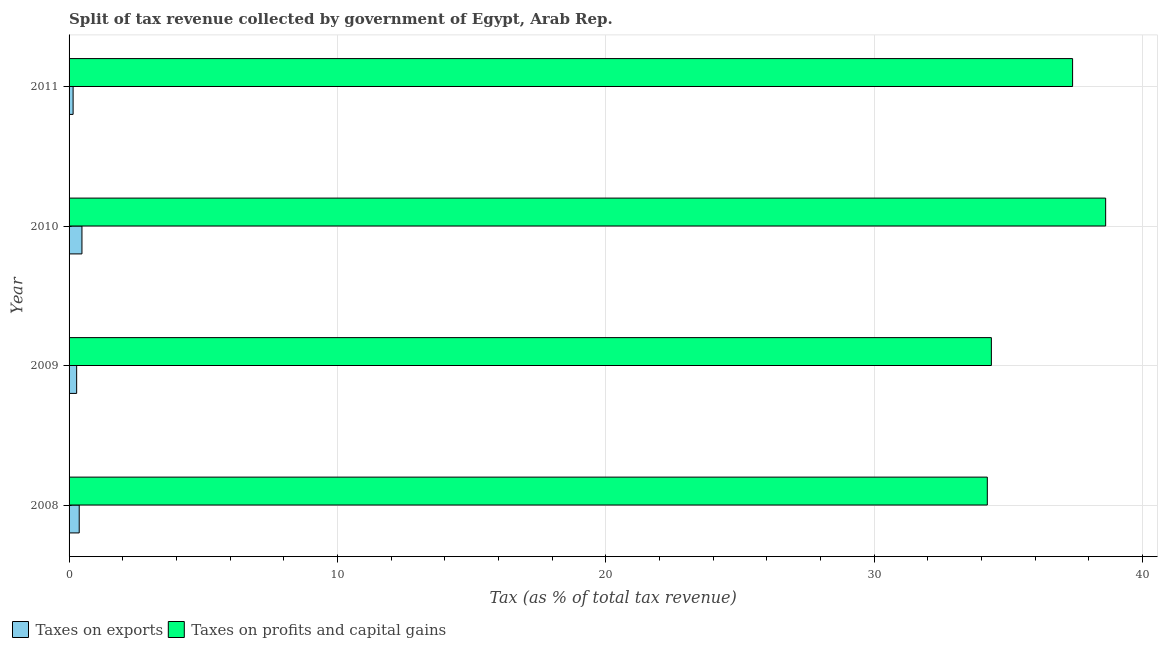Are the number of bars per tick equal to the number of legend labels?
Keep it short and to the point. Yes. How many bars are there on the 1st tick from the top?
Provide a short and direct response. 2. How many bars are there on the 1st tick from the bottom?
Keep it short and to the point. 2. What is the percentage of revenue obtained from taxes on profits and capital gains in 2010?
Offer a terse response. 38.63. Across all years, what is the maximum percentage of revenue obtained from taxes on exports?
Your answer should be very brief. 0.48. Across all years, what is the minimum percentage of revenue obtained from taxes on exports?
Provide a succinct answer. 0.15. In which year was the percentage of revenue obtained from taxes on exports minimum?
Provide a short and direct response. 2011. What is the total percentage of revenue obtained from taxes on exports in the graph?
Offer a terse response. 1.29. What is the difference between the percentage of revenue obtained from taxes on exports in 2008 and that in 2011?
Your response must be concise. 0.23. What is the difference between the percentage of revenue obtained from taxes on exports in 2011 and the percentage of revenue obtained from taxes on profits and capital gains in 2009?
Offer a very short reply. -34.22. What is the average percentage of revenue obtained from taxes on profits and capital gains per year?
Offer a very short reply. 36.15. In the year 2010, what is the difference between the percentage of revenue obtained from taxes on profits and capital gains and percentage of revenue obtained from taxes on exports?
Offer a terse response. 38.15. In how many years, is the percentage of revenue obtained from taxes on exports greater than 6 %?
Your answer should be compact. 0. What is the ratio of the percentage of revenue obtained from taxes on profits and capital gains in 2008 to that in 2011?
Ensure brevity in your answer.  0.92. Is the difference between the percentage of revenue obtained from taxes on profits and capital gains in 2010 and 2011 greater than the difference between the percentage of revenue obtained from taxes on exports in 2010 and 2011?
Provide a short and direct response. Yes. What is the difference between the highest and the second highest percentage of revenue obtained from taxes on profits and capital gains?
Ensure brevity in your answer.  1.23. What is the difference between the highest and the lowest percentage of revenue obtained from taxes on profits and capital gains?
Offer a terse response. 4.41. In how many years, is the percentage of revenue obtained from taxes on profits and capital gains greater than the average percentage of revenue obtained from taxes on profits and capital gains taken over all years?
Give a very brief answer. 2. Is the sum of the percentage of revenue obtained from taxes on profits and capital gains in 2008 and 2011 greater than the maximum percentage of revenue obtained from taxes on exports across all years?
Give a very brief answer. Yes. What does the 1st bar from the top in 2008 represents?
Provide a short and direct response. Taxes on profits and capital gains. What does the 1st bar from the bottom in 2008 represents?
Ensure brevity in your answer.  Taxes on exports. How many years are there in the graph?
Your answer should be very brief. 4. What is the difference between two consecutive major ticks on the X-axis?
Ensure brevity in your answer.  10. Are the values on the major ticks of X-axis written in scientific E-notation?
Offer a very short reply. No. Where does the legend appear in the graph?
Your answer should be compact. Bottom left. How are the legend labels stacked?
Ensure brevity in your answer.  Horizontal. What is the title of the graph?
Make the answer very short. Split of tax revenue collected by government of Egypt, Arab Rep. What is the label or title of the X-axis?
Offer a very short reply. Tax (as % of total tax revenue). What is the label or title of the Y-axis?
Provide a succinct answer. Year. What is the Tax (as % of total tax revenue) of Taxes on exports in 2008?
Offer a terse response. 0.38. What is the Tax (as % of total tax revenue) of Taxes on profits and capital gains in 2008?
Provide a short and direct response. 34.22. What is the Tax (as % of total tax revenue) in Taxes on exports in 2009?
Provide a succinct answer. 0.28. What is the Tax (as % of total tax revenue) of Taxes on profits and capital gains in 2009?
Offer a terse response. 34.37. What is the Tax (as % of total tax revenue) of Taxes on exports in 2010?
Ensure brevity in your answer.  0.48. What is the Tax (as % of total tax revenue) of Taxes on profits and capital gains in 2010?
Your answer should be compact. 38.63. What is the Tax (as % of total tax revenue) in Taxes on exports in 2011?
Offer a terse response. 0.15. What is the Tax (as % of total tax revenue) of Taxes on profits and capital gains in 2011?
Keep it short and to the point. 37.39. Across all years, what is the maximum Tax (as % of total tax revenue) in Taxes on exports?
Offer a very short reply. 0.48. Across all years, what is the maximum Tax (as % of total tax revenue) of Taxes on profits and capital gains?
Your answer should be very brief. 38.63. Across all years, what is the minimum Tax (as % of total tax revenue) of Taxes on exports?
Make the answer very short. 0.15. Across all years, what is the minimum Tax (as % of total tax revenue) in Taxes on profits and capital gains?
Your response must be concise. 34.22. What is the total Tax (as % of total tax revenue) in Taxes on exports in the graph?
Your answer should be very brief. 1.29. What is the total Tax (as % of total tax revenue) in Taxes on profits and capital gains in the graph?
Provide a short and direct response. 144.6. What is the difference between the Tax (as % of total tax revenue) of Taxes on exports in 2008 and that in 2009?
Keep it short and to the point. 0.1. What is the difference between the Tax (as % of total tax revenue) of Taxes on profits and capital gains in 2008 and that in 2009?
Your response must be concise. -0.15. What is the difference between the Tax (as % of total tax revenue) in Taxes on exports in 2008 and that in 2010?
Your response must be concise. -0.1. What is the difference between the Tax (as % of total tax revenue) in Taxes on profits and capital gains in 2008 and that in 2010?
Offer a very short reply. -4.41. What is the difference between the Tax (as % of total tax revenue) in Taxes on exports in 2008 and that in 2011?
Your answer should be compact. 0.23. What is the difference between the Tax (as % of total tax revenue) in Taxes on profits and capital gains in 2008 and that in 2011?
Your answer should be very brief. -3.18. What is the difference between the Tax (as % of total tax revenue) in Taxes on exports in 2009 and that in 2010?
Offer a terse response. -0.2. What is the difference between the Tax (as % of total tax revenue) in Taxes on profits and capital gains in 2009 and that in 2010?
Your answer should be compact. -4.26. What is the difference between the Tax (as % of total tax revenue) of Taxes on exports in 2009 and that in 2011?
Provide a succinct answer. 0.13. What is the difference between the Tax (as % of total tax revenue) of Taxes on profits and capital gains in 2009 and that in 2011?
Ensure brevity in your answer.  -3.03. What is the difference between the Tax (as % of total tax revenue) of Taxes on exports in 2010 and that in 2011?
Make the answer very short. 0.33. What is the difference between the Tax (as % of total tax revenue) in Taxes on profits and capital gains in 2010 and that in 2011?
Offer a very short reply. 1.23. What is the difference between the Tax (as % of total tax revenue) of Taxes on exports in 2008 and the Tax (as % of total tax revenue) of Taxes on profits and capital gains in 2009?
Provide a short and direct response. -33.99. What is the difference between the Tax (as % of total tax revenue) of Taxes on exports in 2008 and the Tax (as % of total tax revenue) of Taxes on profits and capital gains in 2010?
Your answer should be compact. -38.25. What is the difference between the Tax (as % of total tax revenue) of Taxes on exports in 2008 and the Tax (as % of total tax revenue) of Taxes on profits and capital gains in 2011?
Make the answer very short. -37.02. What is the difference between the Tax (as % of total tax revenue) in Taxes on exports in 2009 and the Tax (as % of total tax revenue) in Taxes on profits and capital gains in 2010?
Offer a very short reply. -38.34. What is the difference between the Tax (as % of total tax revenue) in Taxes on exports in 2009 and the Tax (as % of total tax revenue) in Taxes on profits and capital gains in 2011?
Offer a terse response. -37.11. What is the difference between the Tax (as % of total tax revenue) of Taxes on exports in 2010 and the Tax (as % of total tax revenue) of Taxes on profits and capital gains in 2011?
Make the answer very short. -36.91. What is the average Tax (as % of total tax revenue) in Taxes on exports per year?
Provide a short and direct response. 0.32. What is the average Tax (as % of total tax revenue) in Taxes on profits and capital gains per year?
Keep it short and to the point. 36.15. In the year 2008, what is the difference between the Tax (as % of total tax revenue) in Taxes on exports and Tax (as % of total tax revenue) in Taxes on profits and capital gains?
Make the answer very short. -33.84. In the year 2009, what is the difference between the Tax (as % of total tax revenue) in Taxes on exports and Tax (as % of total tax revenue) in Taxes on profits and capital gains?
Offer a terse response. -34.09. In the year 2010, what is the difference between the Tax (as % of total tax revenue) in Taxes on exports and Tax (as % of total tax revenue) in Taxes on profits and capital gains?
Keep it short and to the point. -38.15. In the year 2011, what is the difference between the Tax (as % of total tax revenue) of Taxes on exports and Tax (as % of total tax revenue) of Taxes on profits and capital gains?
Provide a succinct answer. -37.24. What is the ratio of the Tax (as % of total tax revenue) in Taxes on exports in 2008 to that in 2009?
Offer a terse response. 1.34. What is the ratio of the Tax (as % of total tax revenue) in Taxes on exports in 2008 to that in 2010?
Your response must be concise. 0.79. What is the ratio of the Tax (as % of total tax revenue) of Taxes on profits and capital gains in 2008 to that in 2010?
Offer a very short reply. 0.89. What is the ratio of the Tax (as % of total tax revenue) in Taxes on exports in 2008 to that in 2011?
Provide a succinct answer. 2.51. What is the ratio of the Tax (as % of total tax revenue) in Taxes on profits and capital gains in 2008 to that in 2011?
Provide a short and direct response. 0.92. What is the ratio of the Tax (as % of total tax revenue) in Taxes on exports in 2009 to that in 2010?
Offer a terse response. 0.59. What is the ratio of the Tax (as % of total tax revenue) in Taxes on profits and capital gains in 2009 to that in 2010?
Provide a short and direct response. 0.89. What is the ratio of the Tax (as % of total tax revenue) of Taxes on exports in 2009 to that in 2011?
Offer a terse response. 1.87. What is the ratio of the Tax (as % of total tax revenue) of Taxes on profits and capital gains in 2009 to that in 2011?
Provide a succinct answer. 0.92. What is the ratio of the Tax (as % of total tax revenue) of Taxes on exports in 2010 to that in 2011?
Offer a terse response. 3.19. What is the ratio of the Tax (as % of total tax revenue) in Taxes on profits and capital gains in 2010 to that in 2011?
Give a very brief answer. 1.03. What is the difference between the highest and the second highest Tax (as % of total tax revenue) in Taxes on exports?
Provide a short and direct response. 0.1. What is the difference between the highest and the second highest Tax (as % of total tax revenue) in Taxes on profits and capital gains?
Your answer should be compact. 1.23. What is the difference between the highest and the lowest Tax (as % of total tax revenue) of Taxes on exports?
Give a very brief answer. 0.33. What is the difference between the highest and the lowest Tax (as % of total tax revenue) in Taxes on profits and capital gains?
Your answer should be compact. 4.41. 